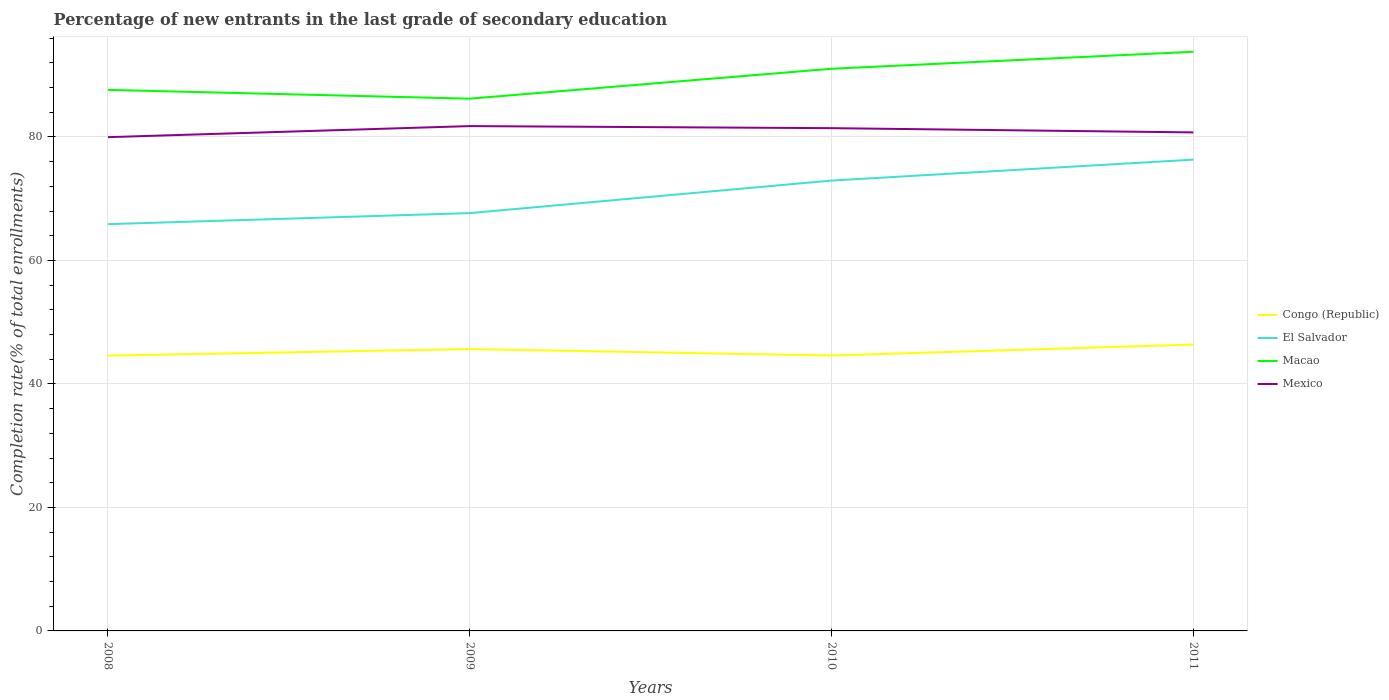Is the number of lines equal to the number of legend labels?
Provide a succinct answer. Yes. Across all years, what is the maximum percentage of new entrants in Macao?
Ensure brevity in your answer.  86.21. What is the total percentage of new entrants in El Salvador in the graph?
Make the answer very short. -5.27. What is the difference between the highest and the second highest percentage of new entrants in Macao?
Offer a terse response. 7.59. What is the difference between the highest and the lowest percentage of new entrants in Congo (Republic)?
Offer a very short reply. 2. Is the percentage of new entrants in El Salvador strictly greater than the percentage of new entrants in Congo (Republic) over the years?
Make the answer very short. No. Are the values on the major ticks of Y-axis written in scientific E-notation?
Provide a succinct answer. No. Does the graph contain any zero values?
Offer a terse response. No. What is the title of the graph?
Give a very brief answer. Percentage of new entrants in the last grade of secondary education. Does "Tuvalu" appear as one of the legend labels in the graph?
Your response must be concise. No. What is the label or title of the X-axis?
Make the answer very short. Years. What is the label or title of the Y-axis?
Your answer should be very brief. Completion rate(% of total enrollments). What is the Completion rate(% of total enrollments) in Congo (Republic) in 2008?
Your answer should be very brief. 44.59. What is the Completion rate(% of total enrollments) in El Salvador in 2008?
Give a very brief answer. 65.88. What is the Completion rate(% of total enrollments) of Macao in 2008?
Offer a terse response. 87.63. What is the Completion rate(% of total enrollments) of Mexico in 2008?
Ensure brevity in your answer.  79.97. What is the Completion rate(% of total enrollments) in Congo (Republic) in 2009?
Your response must be concise. 45.65. What is the Completion rate(% of total enrollments) in El Salvador in 2009?
Your answer should be very brief. 67.67. What is the Completion rate(% of total enrollments) of Macao in 2009?
Your answer should be very brief. 86.21. What is the Completion rate(% of total enrollments) in Mexico in 2009?
Give a very brief answer. 81.76. What is the Completion rate(% of total enrollments) in Congo (Republic) in 2010?
Provide a short and direct response. 44.61. What is the Completion rate(% of total enrollments) of El Salvador in 2010?
Your answer should be compact. 72.94. What is the Completion rate(% of total enrollments) in Macao in 2010?
Offer a terse response. 91.05. What is the Completion rate(% of total enrollments) in Mexico in 2010?
Provide a short and direct response. 81.43. What is the Completion rate(% of total enrollments) in Congo (Republic) in 2011?
Offer a very short reply. 46.38. What is the Completion rate(% of total enrollments) of El Salvador in 2011?
Make the answer very short. 76.33. What is the Completion rate(% of total enrollments) in Macao in 2011?
Your answer should be compact. 93.8. What is the Completion rate(% of total enrollments) of Mexico in 2011?
Your answer should be very brief. 80.74. Across all years, what is the maximum Completion rate(% of total enrollments) in Congo (Republic)?
Keep it short and to the point. 46.38. Across all years, what is the maximum Completion rate(% of total enrollments) in El Salvador?
Provide a succinct answer. 76.33. Across all years, what is the maximum Completion rate(% of total enrollments) of Macao?
Your answer should be compact. 93.8. Across all years, what is the maximum Completion rate(% of total enrollments) in Mexico?
Provide a short and direct response. 81.76. Across all years, what is the minimum Completion rate(% of total enrollments) in Congo (Republic)?
Ensure brevity in your answer.  44.59. Across all years, what is the minimum Completion rate(% of total enrollments) in El Salvador?
Your answer should be compact. 65.88. Across all years, what is the minimum Completion rate(% of total enrollments) of Macao?
Ensure brevity in your answer.  86.21. Across all years, what is the minimum Completion rate(% of total enrollments) of Mexico?
Your answer should be very brief. 79.97. What is the total Completion rate(% of total enrollments) in Congo (Republic) in the graph?
Offer a terse response. 181.22. What is the total Completion rate(% of total enrollments) in El Salvador in the graph?
Offer a terse response. 282.82. What is the total Completion rate(% of total enrollments) in Macao in the graph?
Your response must be concise. 358.68. What is the total Completion rate(% of total enrollments) in Mexico in the graph?
Your answer should be compact. 323.9. What is the difference between the Completion rate(% of total enrollments) in Congo (Republic) in 2008 and that in 2009?
Provide a short and direct response. -1.05. What is the difference between the Completion rate(% of total enrollments) in El Salvador in 2008 and that in 2009?
Your response must be concise. -1.79. What is the difference between the Completion rate(% of total enrollments) in Macao in 2008 and that in 2009?
Your answer should be compact. 1.42. What is the difference between the Completion rate(% of total enrollments) of Mexico in 2008 and that in 2009?
Ensure brevity in your answer.  -1.79. What is the difference between the Completion rate(% of total enrollments) of Congo (Republic) in 2008 and that in 2010?
Keep it short and to the point. -0.01. What is the difference between the Completion rate(% of total enrollments) of El Salvador in 2008 and that in 2010?
Ensure brevity in your answer.  -7.06. What is the difference between the Completion rate(% of total enrollments) of Macao in 2008 and that in 2010?
Provide a succinct answer. -3.42. What is the difference between the Completion rate(% of total enrollments) of Mexico in 2008 and that in 2010?
Offer a terse response. -1.46. What is the difference between the Completion rate(% of total enrollments) of Congo (Republic) in 2008 and that in 2011?
Make the answer very short. -1.78. What is the difference between the Completion rate(% of total enrollments) of El Salvador in 2008 and that in 2011?
Give a very brief answer. -10.45. What is the difference between the Completion rate(% of total enrollments) in Macao in 2008 and that in 2011?
Make the answer very short. -6.17. What is the difference between the Completion rate(% of total enrollments) of Mexico in 2008 and that in 2011?
Offer a very short reply. -0.77. What is the difference between the Completion rate(% of total enrollments) in Congo (Republic) in 2009 and that in 2010?
Your response must be concise. 1.04. What is the difference between the Completion rate(% of total enrollments) of El Salvador in 2009 and that in 2010?
Offer a very short reply. -5.27. What is the difference between the Completion rate(% of total enrollments) in Macao in 2009 and that in 2010?
Make the answer very short. -4.84. What is the difference between the Completion rate(% of total enrollments) of Mexico in 2009 and that in 2010?
Your answer should be very brief. 0.33. What is the difference between the Completion rate(% of total enrollments) in Congo (Republic) in 2009 and that in 2011?
Your answer should be very brief. -0.73. What is the difference between the Completion rate(% of total enrollments) in El Salvador in 2009 and that in 2011?
Your answer should be very brief. -8.66. What is the difference between the Completion rate(% of total enrollments) of Macao in 2009 and that in 2011?
Your answer should be very brief. -7.59. What is the difference between the Completion rate(% of total enrollments) of Mexico in 2009 and that in 2011?
Ensure brevity in your answer.  1.02. What is the difference between the Completion rate(% of total enrollments) in Congo (Republic) in 2010 and that in 2011?
Ensure brevity in your answer.  -1.77. What is the difference between the Completion rate(% of total enrollments) in El Salvador in 2010 and that in 2011?
Your response must be concise. -3.39. What is the difference between the Completion rate(% of total enrollments) of Macao in 2010 and that in 2011?
Make the answer very short. -2.75. What is the difference between the Completion rate(% of total enrollments) of Mexico in 2010 and that in 2011?
Keep it short and to the point. 0.69. What is the difference between the Completion rate(% of total enrollments) in Congo (Republic) in 2008 and the Completion rate(% of total enrollments) in El Salvador in 2009?
Your answer should be very brief. -23.07. What is the difference between the Completion rate(% of total enrollments) in Congo (Republic) in 2008 and the Completion rate(% of total enrollments) in Macao in 2009?
Provide a succinct answer. -41.61. What is the difference between the Completion rate(% of total enrollments) of Congo (Republic) in 2008 and the Completion rate(% of total enrollments) of Mexico in 2009?
Give a very brief answer. -37.17. What is the difference between the Completion rate(% of total enrollments) of El Salvador in 2008 and the Completion rate(% of total enrollments) of Macao in 2009?
Give a very brief answer. -20.33. What is the difference between the Completion rate(% of total enrollments) of El Salvador in 2008 and the Completion rate(% of total enrollments) of Mexico in 2009?
Your response must be concise. -15.88. What is the difference between the Completion rate(% of total enrollments) of Macao in 2008 and the Completion rate(% of total enrollments) of Mexico in 2009?
Offer a terse response. 5.87. What is the difference between the Completion rate(% of total enrollments) in Congo (Republic) in 2008 and the Completion rate(% of total enrollments) in El Salvador in 2010?
Make the answer very short. -28.34. What is the difference between the Completion rate(% of total enrollments) of Congo (Republic) in 2008 and the Completion rate(% of total enrollments) of Macao in 2010?
Offer a terse response. -46.45. What is the difference between the Completion rate(% of total enrollments) of Congo (Republic) in 2008 and the Completion rate(% of total enrollments) of Mexico in 2010?
Provide a short and direct response. -36.83. What is the difference between the Completion rate(% of total enrollments) in El Salvador in 2008 and the Completion rate(% of total enrollments) in Macao in 2010?
Your answer should be compact. -25.17. What is the difference between the Completion rate(% of total enrollments) of El Salvador in 2008 and the Completion rate(% of total enrollments) of Mexico in 2010?
Your answer should be compact. -15.55. What is the difference between the Completion rate(% of total enrollments) in Macao in 2008 and the Completion rate(% of total enrollments) in Mexico in 2010?
Your answer should be very brief. 6.2. What is the difference between the Completion rate(% of total enrollments) in Congo (Republic) in 2008 and the Completion rate(% of total enrollments) in El Salvador in 2011?
Keep it short and to the point. -31.74. What is the difference between the Completion rate(% of total enrollments) in Congo (Republic) in 2008 and the Completion rate(% of total enrollments) in Macao in 2011?
Provide a short and direct response. -49.21. What is the difference between the Completion rate(% of total enrollments) of Congo (Republic) in 2008 and the Completion rate(% of total enrollments) of Mexico in 2011?
Provide a succinct answer. -36.14. What is the difference between the Completion rate(% of total enrollments) of El Salvador in 2008 and the Completion rate(% of total enrollments) of Macao in 2011?
Provide a short and direct response. -27.92. What is the difference between the Completion rate(% of total enrollments) in El Salvador in 2008 and the Completion rate(% of total enrollments) in Mexico in 2011?
Your answer should be very brief. -14.86. What is the difference between the Completion rate(% of total enrollments) in Macao in 2008 and the Completion rate(% of total enrollments) in Mexico in 2011?
Give a very brief answer. 6.89. What is the difference between the Completion rate(% of total enrollments) in Congo (Republic) in 2009 and the Completion rate(% of total enrollments) in El Salvador in 2010?
Ensure brevity in your answer.  -27.29. What is the difference between the Completion rate(% of total enrollments) in Congo (Republic) in 2009 and the Completion rate(% of total enrollments) in Macao in 2010?
Your answer should be very brief. -45.4. What is the difference between the Completion rate(% of total enrollments) in Congo (Republic) in 2009 and the Completion rate(% of total enrollments) in Mexico in 2010?
Offer a very short reply. -35.78. What is the difference between the Completion rate(% of total enrollments) in El Salvador in 2009 and the Completion rate(% of total enrollments) in Macao in 2010?
Your answer should be compact. -23.38. What is the difference between the Completion rate(% of total enrollments) in El Salvador in 2009 and the Completion rate(% of total enrollments) in Mexico in 2010?
Provide a succinct answer. -13.76. What is the difference between the Completion rate(% of total enrollments) of Macao in 2009 and the Completion rate(% of total enrollments) of Mexico in 2010?
Offer a terse response. 4.78. What is the difference between the Completion rate(% of total enrollments) in Congo (Republic) in 2009 and the Completion rate(% of total enrollments) in El Salvador in 2011?
Make the answer very short. -30.69. What is the difference between the Completion rate(% of total enrollments) of Congo (Republic) in 2009 and the Completion rate(% of total enrollments) of Macao in 2011?
Give a very brief answer. -48.15. What is the difference between the Completion rate(% of total enrollments) of Congo (Republic) in 2009 and the Completion rate(% of total enrollments) of Mexico in 2011?
Give a very brief answer. -35.09. What is the difference between the Completion rate(% of total enrollments) in El Salvador in 2009 and the Completion rate(% of total enrollments) in Macao in 2011?
Provide a succinct answer. -26.13. What is the difference between the Completion rate(% of total enrollments) of El Salvador in 2009 and the Completion rate(% of total enrollments) of Mexico in 2011?
Make the answer very short. -13.07. What is the difference between the Completion rate(% of total enrollments) of Macao in 2009 and the Completion rate(% of total enrollments) of Mexico in 2011?
Provide a short and direct response. 5.47. What is the difference between the Completion rate(% of total enrollments) in Congo (Republic) in 2010 and the Completion rate(% of total enrollments) in El Salvador in 2011?
Ensure brevity in your answer.  -31.73. What is the difference between the Completion rate(% of total enrollments) in Congo (Republic) in 2010 and the Completion rate(% of total enrollments) in Macao in 2011?
Make the answer very short. -49.19. What is the difference between the Completion rate(% of total enrollments) of Congo (Republic) in 2010 and the Completion rate(% of total enrollments) of Mexico in 2011?
Your answer should be compact. -36.13. What is the difference between the Completion rate(% of total enrollments) in El Salvador in 2010 and the Completion rate(% of total enrollments) in Macao in 2011?
Ensure brevity in your answer.  -20.86. What is the difference between the Completion rate(% of total enrollments) in El Salvador in 2010 and the Completion rate(% of total enrollments) in Mexico in 2011?
Ensure brevity in your answer.  -7.8. What is the difference between the Completion rate(% of total enrollments) of Macao in 2010 and the Completion rate(% of total enrollments) of Mexico in 2011?
Your answer should be very brief. 10.31. What is the average Completion rate(% of total enrollments) of Congo (Republic) per year?
Offer a terse response. 45.31. What is the average Completion rate(% of total enrollments) of El Salvador per year?
Your answer should be very brief. 70.7. What is the average Completion rate(% of total enrollments) of Macao per year?
Provide a short and direct response. 89.67. What is the average Completion rate(% of total enrollments) of Mexico per year?
Ensure brevity in your answer.  80.97. In the year 2008, what is the difference between the Completion rate(% of total enrollments) in Congo (Republic) and Completion rate(% of total enrollments) in El Salvador?
Provide a short and direct response. -21.29. In the year 2008, what is the difference between the Completion rate(% of total enrollments) in Congo (Republic) and Completion rate(% of total enrollments) in Macao?
Provide a short and direct response. -43.03. In the year 2008, what is the difference between the Completion rate(% of total enrollments) in Congo (Republic) and Completion rate(% of total enrollments) in Mexico?
Keep it short and to the point. -35.38. In the year 2008, what is the difference between the Completion rate(% of total enrollments) of El Salvador and Completion rate(% of total enrollments) of Macao?
Ensure brevity in your answer.  -21.75. In the year 2008, what is the difference between the Completion rate(% of total enrollments) in El Salvador and Completion rate(% of total enrollments) in Mexico?
Offer a very short reply. -14.09. In the year 2008, what is the difference between the Completion rate(% of total enrollments) in Macao and Completion rate(% of total enrollments) in Mexico?
Give a very brief answer. 7.66. In the year 2009, what is the difference between the Completion rate(% of total enrollments) of Congo (Republic) and Completion rate(% of total enrollments) of El Salvador?
Provide a short and direct response. -22.02. In the year 2009, what is the difference between the Completion rate(% of total enrollments) in Congo (Republic) and Completion rate(% of total enrollments) in Macao?
Ensure brevity in your answer.  -40.56. In the year 2009, what is the difference between the Completion rate(% of total enrollments) of Congo (Republic) and Completion rate(% of total enrollments) of Mexico?
Your answer should be very brief. -36.12. In the year 2009, what is the difference between the Completion rate(% of total enrollments) of El Salvador and Completion rate(% of total enrollments) of Macao?
Provide a succinct answer. -18.54. In the year 2009, what is the difference between the Completion rate(% of total enrollments) of El Salvador and Completion rate(% of total enrollments) of Mexico?
Provide a succinct answer. -14.09. In the year 2009, what is the difference between the Completion rate(% of total enrollments) of Macao and Completion rate(% of total enrollments) of Mexico?
Make the answer very short. 4.44. In the year 2010, what is the difference between the Completion rate(% of total enrollments) in Congo (Republic) and Completion rate(% of total enrollments) in El Salvador?
Your response must be concise. -28.33. In the year 2010, what is the difference between the Completion rate(% of total enrollments) in Congo (Republic) and Completion rate(% of total enrollments) in Macao?
Keep it short and to the point. -46.44. In the year 2010, what is the difference between the Completion rate(% of total enrollments) of Congo (Republic) and Completion rate(% of total enrollments) of Mexico?
Your answer should be very brief. -36.82. In the year 2010, what is the difference between the Completion rate(% of total enrollments) of El Salvador and Completion rate(% of total enrollments) of Macao?
Your answer should be very brief. -18.11. In the year 2010, what is the difference between the Completion rate(% of total enrollments) of El Salvador and Completion rate(% of total enrollments) of Mexico?
Give a very brief answer. -8.49. In the year 2010, what is the difference between the Completion rate(% of total enrollments) of Macao and Completion rate(% of total enrollments) of Mexico?
Your response must be concise. 9.62. In the year 2011, what is the difference between the Completion rate(% of total enrollments) in Congo (Republic) and Completion rate(% of total enrollments) in El Salvador?
Offer a very short reply. -29.95. In the year 2011, what is the difference between the Completion rate(% of total enrollments) of Congo (Republic) and Completion rate(% of total enrollments) of Macao?
Your answer should be very brief. -47.42. In the year 2011, what is the difference between the Completion rate(% of total enrollments) of Congo (Republic) and Completion rate(% of total enrollments) of Mexico?
Your response must be concise. -34.36. In the year 2011, what is the difference between the Completion rate(% of total enrollments) in El Salvador and Completion rate(% of total enrollments) in Macao?
Your answer should be very brief. -17.47. In the year 2011, what is the difference between the Completion rate(% of total enrollments) in El Salvador and Completion rate(% of total enrollments) in Mexico?
Offer a very short reply. -4.41. In the year 2011, what is the difference between the Completion rate(% of total enrollments) of Macao and Completion rate(% of total enrollments) of Mexico?
Offer a very short reply. 13.06. What is the ratio of the Completion rate(% of total enrollments) in El Salvador in 2008 to that in 2009?
Your answer should be compact. 0.97. What is the ratio of the Completion rate(% of total enrollments) of Macao in 2008 to that in 2009?
Your answer should be compact. 1.02. What is the ratio of the Completion rate(% of total enrollments) of Mexico in 2008 to that in 2009?
Offer a terse response. 0.98. What is the ratio of the Completion rate(% of total enrollments) of El Salvador in 2008 to that in 2010?
Offer a terse response. 0.9. What is the ratio of the Completion rate(% of total enrollments) of Macao in 2008 to that in 2010?
Ensure brevity in your answer.  0.96. What is the ratio of the Completion rate(% of total enrollments) of Mexico in 2008 to that in 2010?
Your answer should be compact. 0.98. What is the ratio of the Completion rate(% of total enrollments) in Congo (Republic) in 2008 to that in 2011?
Give a very brief answer. 0.96. What is the ratio of the Completion rate(% of total enrollments) in El Salvador in 2008 to that in 2011?
Provide a succinct answer. 0.86. What is the ratio of the Completion rate(% of total enrollments) in Macao in 2008 to that in 2011?
Give a very brief answer. 0.93. What is the ratio of the Completion rate(% of total enrollments) in Mexico in 2008 to that in 2011?
Give a very brief answer. 0.99. What is the ratio of the Completion rate(% of total enrollments) of Congo (Republic) in 2009 to that in 2010?
Ensure brevity in your answer.  1.02. What is the ratio of the Completion rate(% of total enrollments) of El Salvador in 2009 to that in 2010?
Ensure brevity in your answer.  0.93. What is the ratio of the Completion rate(% of total enrollments) of Macao in 2009 to that in 2010?
Your answer should be very brief. 0.95. What is the ratio of the Completion rate(% of total enrollments) in Mexico in 2009 to that in 2010?
Ensure brevity in your answer.  1. What is the ratio of the Completion rate(% of total enrollments) of Congo (Republic) in 2009 to that in 2011?
Keep it short and to the point. 0.98. What is the ratio of the Completion rate(% of total enrollments) of El Salvador in 2009 to that in 2011?
Your response must be concise. 0.89. What is the ratio of the Completion rate(% of total enrollments) of Macao in 2009 to that in 2011?
Provide a short and direct response. 0.92. What is the ratio of the Completion rate(% of total enrollments) in Mexico in 2009 to that in 2011?
Give a very brief answer. 1.01. What is the ratio of the Completion rate(% of total enrollments) of Congo (Republic) in 2010 to that in 2011?
Your response must be concise. 0.96. What is the ratio of the Completion rate(% of total enrollments) in El Salvador in 2010 to that in 2011?
Provide a succinct answer. 0.96. What is the ratio of the Completion rate(% of total enrollments) of Macao in 2010 to that in 2011?
Keep it short and to the point. 0.97. What is the ratio of the Completion rate(% of total enrollments) in Mexico in 2010 to that in 2011?
Provide a succinct answer. 1.01. What is the difference between the highest and the second highest Completion rate(% of total enrollments) of Congo (Republic)?
Provide a short and direct response. 0.73. What is the difference between the highest and the second highest Completion rate(% of total enrollments) in El Salvador?
Your answer should be very brief. 3.39. What is the difference between the highest and the second highest Completion rate(% of total enrollments) of Macao?
Offer a very short reply. 2.75. What is the difference between the highest and the second highest Completion rate(% of total enrollments) in Mexico?
Give a very brief answer. 0.33. What is the difference between the highest and the lowest Completion rate(% of total enrollments) in Congo (Republic)?
Offer a very short reply. 1.78. What is the difference between the highest and the lowest Completion rate(% of total enrollments) of El Salvador?
Your answer should be very brief. 10.45. What is the difference between the highest and the lowest Completion rate(% of total enrollments) in Macao?
Give a very brief answer. 7.59. What is the difference between the highest and the lowest Completion rate(% of total enrollments) of Mexico?
Keep it short and to the point. 1.79. 